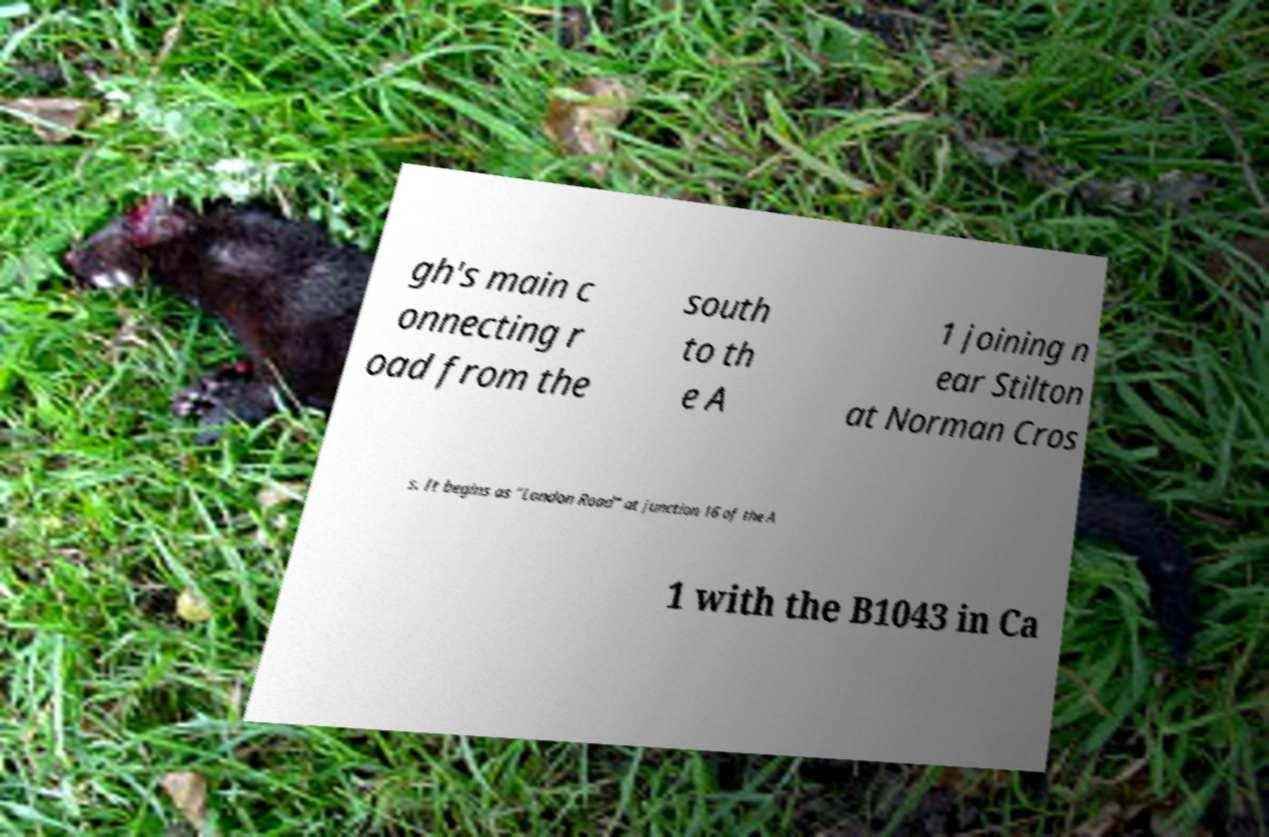Please read and relay the text visible in this image. What does it say? gh's main c onnecting r oad from the south to th e A 1 joining n ear Stilton at Norman Cros s. It begins as "London Road" at junction 16 of the A 1 with the B1043 in Ca 